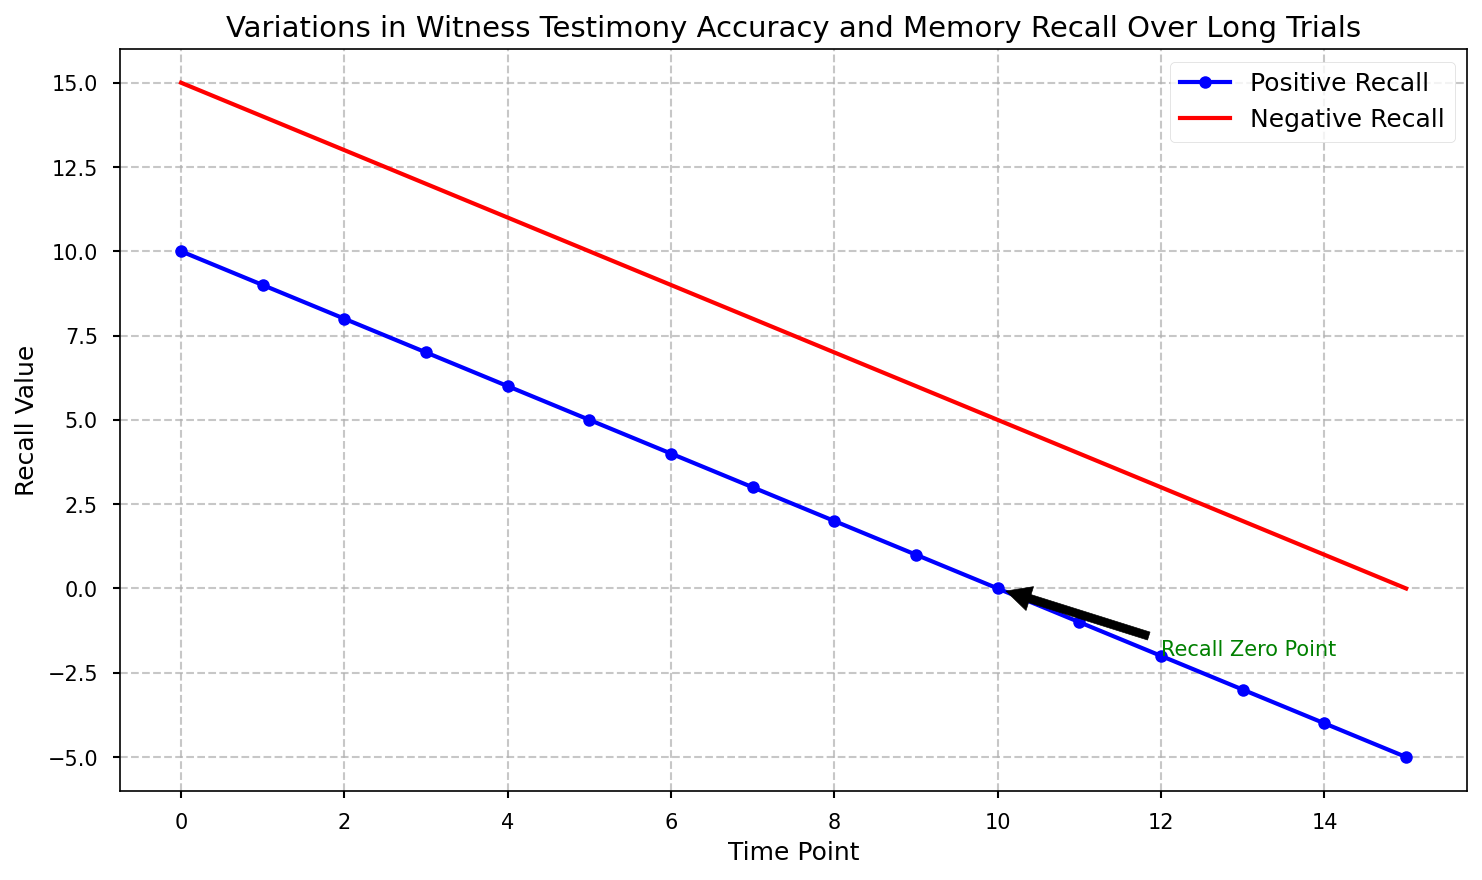What are the general trends of positive and negative recall over the time points? The positive recall values decrease linearly from 10 to -5, indicating a decline in witness accuracy over time. Negative recall values also decrease but at a slower pace, moving from 15 to 0.
Answer: Both recall trends decrease over time At what time point do the positive recall values first become negative? Observing the blue line (positive recall) in the figure, it first dips below zero at time point 11.
Answer: Time point 11 What is the difference in recall values between positive and negative recall at time point 5? Positive recall at time point 5 is 5, and negative recall at the same point is 10. The difference is 10 - 5.
Answer: 5 At which time point do the positive and negative recall values reach zero? Positive recall reaches zero at time point 10, while negative recall reaches zero at time point 15.
Answer: Positive at 10, Negative at 15 Which recall type (positive or negative) starts with a higher value, and what is that value? At the start (time point 0), the negative recall has a higher value of 15 compared to the positive recall value of 10.
Answer: Negative recall, 15 Considering the trend, what would be the estimated negative recall value at time point 16? The linear trend can be extended to predict the next value. As negative recall decreases by 1 each time point, the expected value at time point 16 would be -1 (from 0 at time point 15).
Answer: -1 What is the sum of positive and negative recall values at time point 8? At time point 8, the positive recall is 2, and the negative recall is 7. The sum is 2 + 7.
Answer: 9 By how much did the negative recall decrease from time point 0 to time point 10? At time point 0, negative recall is 15. At time point 10, it is 5. The decrease is calculated as 15 - 5.
Answer: 10 How many time points have a negative positive recall value? Observing the plot, positive recall becomes negative starting from time point 11 and continues to time point 15, making it 5 time points in total.
Answer: 5 Which recall line (positive or negative) intersects with zero first, and what is the significance of this intersection? The positive recall line intersects with zero first at time point 10, which is noted by the annotation "Recall Zero Point". This point indicates the critical moment when witness' positive recall accuracy completely diminishes.
Answer: Positive recall, significance remarks the zero accuracy moment 